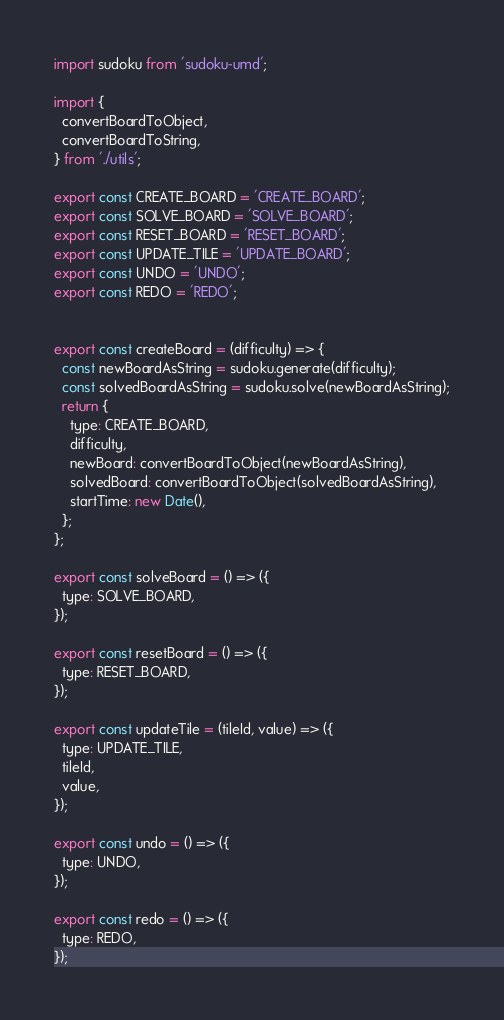Convert code to text. <code><loc_0><loc_0><loc_500><loc_500><_JavaScript_>import sudoku from 'sudoku-umd';

import {
  convertBoardToObject,
  convertBoardToString,
} from './utils';

export const CREATE_BOARD = 'CREATE_BOARD';
export const SOLVE_BOARD = 'SOLVE_BOARD';
export const RESET_BOARD = 'RESET_BOARD';
export const UPDATE_TILE = 'UPDATE_BOARD';
export const UNDO = 'UNDO';
export const REDO = 'REDO';


export const createBoard = (difficulty) => {
  const newBoardAsString = sudoku.generate(difficulty);
  const solvedBoardAsString = sudoku.solve(newBoardAsString);
  return {
    type: CREATE_BOARD,
    difficulty,
    newBoard: convertBoardToObject(newBoardAsString),
    solvedBoard: convertBoardToObject(solvedBoardAsString),
    startTime: new Date(),
  };
};

export const solveBoard = () => ({
  type: SOLVE_BOARD,
});

export const resetBoard = () => ({
  type: RESET_BOARD,
});

export const updateTile = (tileId, value) => ({
  type: UPDATE_TILE,
  tileId,
  value,
});

export const undo = () => ({
  type: UNDO,
});

export const redo = () => ({
  type: REDO,
});
</code> 